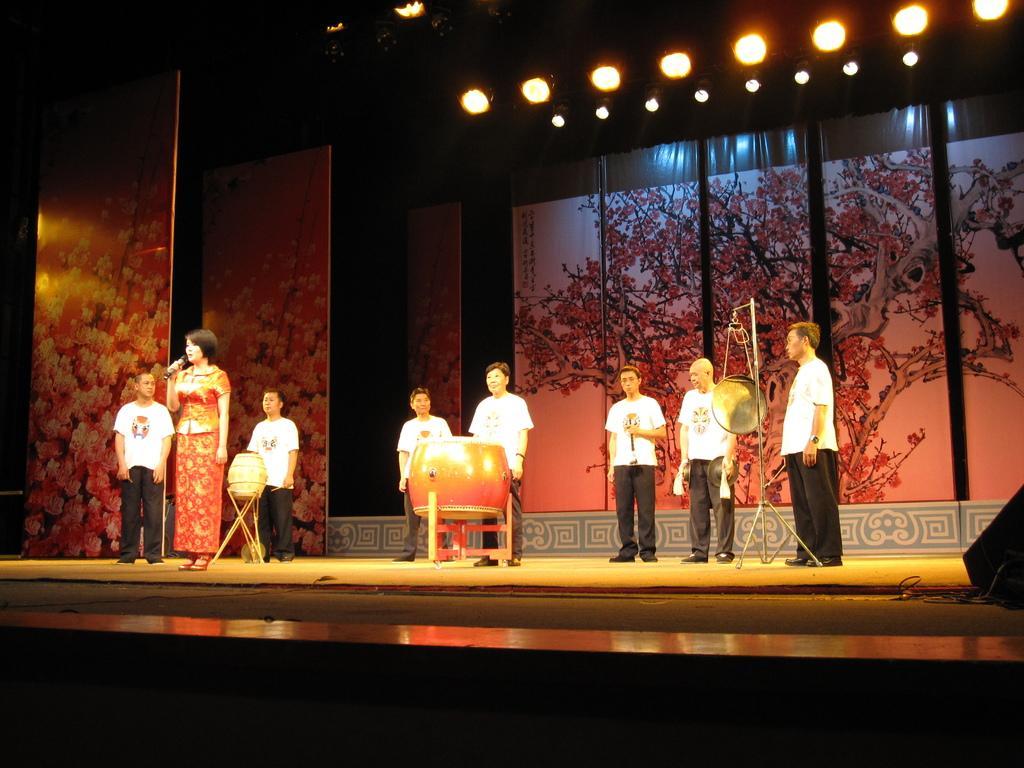Please provide a concise description of this image. In this image, we can see a group of people, musical instruments on the stage. Here a woman is holding a microphone. Background we can see banners. Top of the image, we can see the lights. Right side of the image, we can see black color box on the stage. 